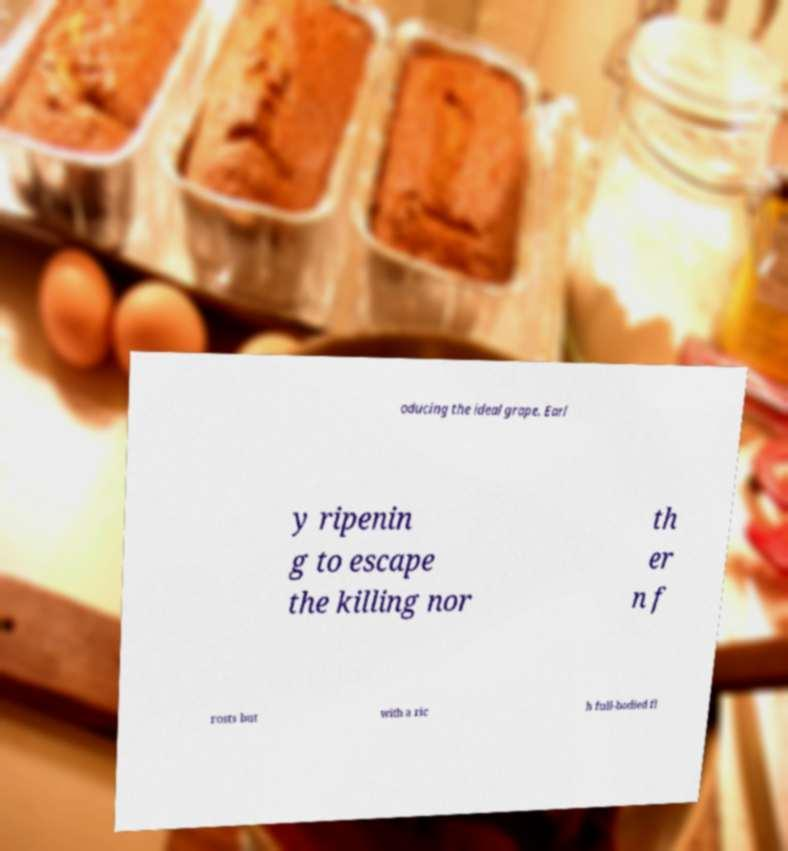Please read and relay the text visible in this image. What does it say? oducing the ideal grape. Earl y ripenin g to escape the killing nor th er n f rosts but with a ric h full-bodied fl 